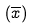<formula> <loc_0><loc_0><loc_500><loc_500>( \overline { x } )</formula> 